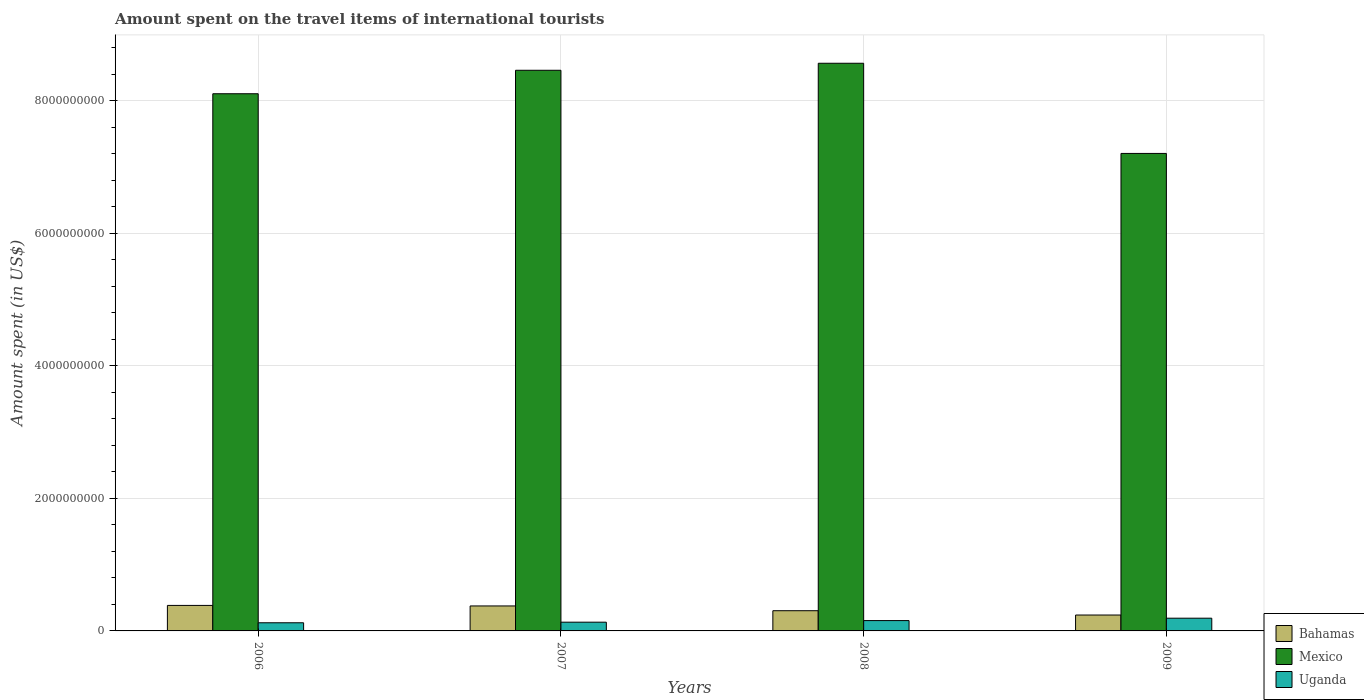How many bars are there on the 1st tick from the left?
Your answer should be compact. 3. How many bars are there on the 4th tick from the right?
Provide a short and direct response. 3. What is the label of the 4th group of bars from the left?
Your response must be concise. 2009. What is the amount spent on the travel items of international tourists in Bahamas in 2008?
Offer a very short reply. 3.05e+08. Across all years, what is the maximum amount spent on the travel items of international tourists in Uganda?
Ensure brevity in your answer.  1.92e+08. Across all years, what is the minimum amount spent on the travel items of international tourists in Bahamas?
Ensure brevity in your answer.  2.40e+08. In which year was the amount spent on the travel items of international tourists in Mexico minimum?
Provide a succinct answer. 2009. What is the total amount spent on the travel items of international tourists in Uganda in the graph?
Your answer should be very brief. 6.03e+08. What is the difference between the amount spent on the travel items of international tourists in Bahamas in 2006 and that in 2007?
Keep it short and to the point. 8.00e+06. What is the difference between the amount spent on the travel items of international tourists in Uganda in 2007 and the amount spent on the travel items of international tourists in Bahamas in 2006?
Offer a terse response. -2.53e+08. What is the average amount spent on the travel items of international tourists in Uganda per year?
Provide a succinct answer. 1.51e+08. In the year 2007, what is the difference between the amount spent on the travel items of international tourists in Mexico and amount spent on the travel items of international tourists in Bahamas?
Ensure brevity in your answer.  8.08e+09. What is the ratio of the amount spent on the travel items of international tourists in Mexico in 2008 to that in 2009?
Give a very brief answer. 1.19. Is the amount spent on the travel items of international tourists in Mexico in 2006 less than that in 2007?
Offer a terse response. Yes. Is the difference between the amount spent on the travel items of international tourists in Mexico in 2007 and 2008 greater than the difference between the amount spent on the travel items of international tourists in Bahamas in 2007 and 2008?
Make the answer very short. No. What is the difference between the highest and the lowest amount spent on the travel items of international tourists in Mexico?
Offer a very short reply. 1.36e+09. In how many years, is the amount spent on the travel items of international tourists in Uganda greater than the average amount spent on the travel items of international tourists in Uganda taken over all years?
Keep it short and to the point. 2. Is the sum of the amount spent on the travel items of international tourists in Uganda in 2007 and 2009 greater than the maximum amount spent on the travel items of international tourists in Bahamas across all years?
Provide a succinct answer. No. What does the 3rd bar from the left in 2008 represents?
Provide a short and direct response. Uganda. What does the 2nd bar from the right in 2006 represents?
Make the answer very short. Mexico. Is it the case that in every year, the sum of the amount spent on the travel items of international tourists in Bahamas and amount spent on the travel items of international tourists in Uganda is greater than the amount spent on the travel items of international tourists in Mexico?
Give a very brief answer. No. How many bars are there?
Make the answer very short. 12. Are all the bars in the graph horizontal?
Keep it short and to the point. No. Does the graph contain any zero values?
Make the answer very short. No. Where does the legend appear in the graph?
Your answer should be very brief. Bottom right. How many legend labels are there?
Provide a succinct answer. 3. What is the title of the graph?
Offer a very short reply. Amount spent on the travel items of international tourists. Does "Benin" appear as one of the legend labels in the graph?
Make the answer very short. No. What is the label or title of the Y-axis?
Provide a succinct answer. Amount spent (in US$). What is the Amount spent (in US$) of Bahamas in 2006?
Ensure brevity in your answer.  3.85e+08. What is the Amount spent (in US$) in Mexico in 2006?
Your answer should be very brief. 8.11e+09. What is the Amount spent (in US$) in Uganda in 2006?
Keep it short and to the point. 1.23e+08. What is the Amount spent (in US$) in Bahamas in 2007?
Provide a short and direct response. 3.77e+08. What is the Amount spent (in US$) in Mexico in 2007?
Offer a very short reply. 8.46e+09. What is the Amount spent (in US$) in Uganda in 2007?
Keep it short and to the point. 1.32e+08. What is the Amount spent (in US$) of Bahamas in 2008?
Make the answer very short. 3.05e+08. What is the Amount spent (in US$) of Mexico in 2008?
Your response must be concise. 8.57e+09. What is the Amount spent (in US$) of Uganda in 2008?
Your answer should be very brief. 1.56e+08. What is the Amount spent (in US$) in Bahamas in 2009?
Your answer should be very brief. 2.40e+08. What is the Amount spent (in US$) in Mexico in 2009?
Ensure brevity in your answer.  7.21e+09. What is the Amount spent (in US$) of Uganda in 2009?
Offer a very short reply. 1.92e+08. Across all years, what is the maximum Amount spent (in US$) in Bahamas?
Keep it short and to the point. 3.85e+08. Across all years, what is the maximum Amount spent (in US$) of Mexico?
Offer a terse response. 8.57e+09. Across all years, what is the maximum Amount spent (in US$) of Uganda?
Provide a short and direct response. 1.92e+08. Across all years, what is the minimum Amount spent (in US$) in Bahamas?
Provide a short and direct response. 2.40e+08. Across all years, what is the minimum Amount spent (in US$) of Mexico?
Provide a short and direct response. 7.21e+09. Across all years, what is the minimum Amount spent (in US$) in Uganda?
Your answer should be compact. 1.23e+08. What is the total Amount spent (in US$) of Bahamas in the graph?
Offer a terse response. 1.31e+09. What is the total Amount spent (in US$) in Mexico in the graph?
Your answer should be compact. 3.23e+1. What is the total Amount spent (in US$) in Uganda in the graph?
Keep it short and to the point. 6.03e+08. What is the difference between the Amount spent (in US$) in Mexico in 2006 and that in 2007?
Your response must be concise. -3.54e+08. What is the difference between the Amount spent (in US$) in Uganda in 2006 and that in 2007?
Your answer should be compact. -9.00e+06. What is the difference between the Amount spent (in US$) in Bahamas in 2006 and that in 2008?
Keep it short and to the point. 8.00e+07. What is the difference between the Amount spent (in US$) in Mexico in 2006 and that in 2008?
Your answer should be very brief. -4.60e+08. What is the difference between the Amount spent (in US$) in Uganda in 2006 and that in 2008?
Offer a terse response. -3.30e+07. What is the difference between the Amount spent (in US$) of Bahamas in 2006 and that in 2009?
Provide a short and direct response. 1.45e+08. What is the difference between the Amount spent (in US$) in Mexico in 2006 and that in 2009?
Make the answer very short. 9.01e+08. What is the difference between the Amount spent (in US$) of Uganda in 2006 and that in 2009?
Provide a short and direct response. -6.90e+07. What is the difference between the Amount spent (in US$) of Bahamas in 2007 and that in 2008?
Provide a short and direct response. 7.20e+07. What is the difference between the Amount spent (in US$) of Mexico in 2007 and that in 2008?
Ensure brevity in your answer.  -1.06e+08. What is the difference between the Amount spent (in US$) in Uganda in 2007 and that in 2008?
Give a very brief answer. -2.40e+07. What is the difference between the Amount spent (in US$) in Bahamas in 2007 and that in 2009?
Offer a very short reply. 1.37e+08. What is the difference between the Amount spent (in US$) in Mexico in 2007 and that in 2009?
Provide a short and direct response. 1.26e+09. What is the difference between the Amount spent (in US$) in Uganda in 2007 and that in 2009?
Offer a terse response. -6.00e+07. What is the difference between the Amount spent (in US$) of Bahamas in 2008 and that in 2009?
Give a very brief answer. 6.50e+07. What is the difference between the Amount spent (in US$) of Mexico in 2008 and that in 2009?
Provide a short and direct response. 1.36e+09. What is the difference between the Amount spent (in US$) in Uganda in 2008 and that in 2009?
Your answer should be compact. -3.60e+07. What is the difference between the Amount spent (in US$) of Bahamas in 2006 and the Amount spent (in US$) of Mexico in 2007?
Give a very brief answer. -8.08e+09. What is the difference between the Amount spent (in US$) in Bahamas in 2006 and the Amount spent (in US$) in Uganda in 2007?
Provide a short and direct response. 2.53e+08. What is the difference between the Amount spent (in US$) of Mexico in 2006 and the Amount spent (in US$) of Uganda in 2007?
Offer a terse response. 7.98e+09. What is the difference between the Amount spent (in US$) in Bahamas in 2006 and the Amount spent (in US$) in Mexico in 2008?
Your response must be concise. -8.18e+09. What is the difference between the Amount spent (in US$) of Bahamas in 2006 and the Amount spent (in US$) of Uganda in 2008?
Your answer should be very brief. 2.29e+08. What is the difference between the Amount spent (in US$) in Mexico in 2006 and the Amount spent (in US$) in Uganda in 2008?
Ensure brevity in your answer.  7.95e+09. What is the difference between the Amount spent (in US$) in Bahamas in 2006 and the Amount spent (in US$) in Mexico in 2009?
Make the answer very short. -6.82e+09. What is the difference between the Amount spent (in US$) in Bahamas in 2006 and the Amount spent (in US$) in Uganda in 2009?
Provide a short and direct response. 1.93e+08. What is the difference between the Amount spent (in US$) of Mexico in 2006 and the Amount spent (in US$) of Uganda in 2009?
Offer a terse response. 7.92e+09. What is the difference between the Amount spent (in US$) of Bahamas in 2007 and the Amount spent (in US$) of Mexico in 2008?
Make the answer very short. -8.19e+09. What is the difference between the Amount spent (in US$) in Bahamas in 2007 and the Amount spent (in US$) in Uganda in 2008?
Provide a short and direct response. 2.21e+08. What is the difference between the Amount spent (in US$) in Mexico in 2007 and the Amount spent (in US$) in Uganda in 2008?
Give a very brief answer. 8.31e+09. What is the difference between the Amount spent (in US$) in Bahamas in 2007 and the Amount spent (in US$) in Mexico in 2009?
Your answer should be compact. -6.83e+09. What is the difference between the Amount spent (in US$) in Bahamas in 2007 and the Amount spent (in US$) in Uganda in 2009?
Make the answer very short. 1.85e+08. What is the difference between the Amount spent (in US$) in Mexico in 2007 and the Amount spent (in US$) in Uganda in 2009?
Give a very brief answer. 8.27e+09. What is the difference between the Amount spent (in US$) of Bahamas in 2008 and the Amount spent (in US$) of Mexico in 2009?
Ensure brevity in your answer.  -6.90e+09. What is the difference between the Amount spent (in US$) in Bahamas in 2008 and the Amount spent (in US$) in Uganda in 2009?
Provide a succinct answer. 1.13e+08. What is the difference between the Amount spent (in US$) of Mexico in 2008 and the Amount spent (in US$) of Uganda in 2009?
Your answer should be compact. 8.38e+09. What is the average Amount spent (in US$) of Bahamas per year?
Your answer should be very brief. 3.27e+08. What is the average Amount spent (in US$) in Mexico per year?
Ensure brevity in your answer.  8.09e+09. What is the average Amount spent (in US$) of Uganda per year?
Your answer should be compact. 1.51e+08. In the year 2006, what is the difference between the Amount spent (in US$) of Bahamas and Amount spent (in US$) of Mexico?
Offer a terse response. -7.72e+09. In the year 2006, what is the difference between the Amount spent (in US$) of Bahamas and Amount spent (in US$) of Uganda?
Your answer should be compact. 2.62e+08. In the year 2006, what is the difference between the Amount spent (in US$) of Mexico and Amount spent (in US$) of Uganda?
Provide a short and direct response. 7.98e+09. In the year 2007, what is the difference between the Amount spent (in US$) in Bahamas and Amount spent (in US$) in Mexico?
Ensure brevity in your answer.  -8.08e+09. In the year 2007, what is the difference between the Amount spent (in US$) of Bahamas and Amount spent (in US$) of Uganda?
Give a very brief answer. 2.45e+08. In the year 2007, what is the difference between the Amount spent (in US$) of Mexico and Amount spent (in US$) of Uganda?
Offer a terse response. 8.33e+09. In the year 2008, what is the difference between the Amount spent (in US$) in Bahamas and Amount spent (in US$) in Mexico?
Your response must be concise. -8.26e+09. In the year 2008, what is the difference between the Amount spent (in US$) of Bahamas and Amount spent (in US$) of Uganda?
Your response must be concise. 1.49e+08. In the year 2008, what is the difference between the Amount spent (in US$) of Mexico and Amount spent (in US$) of Uganda?
Your response must be concise. 8.41e+09. In the year 2009, what is the difference between the Amount spent (in US$) in Bahamas and Amount spent (in US$) in Mexico?
Keep it short and to the point. -6.97e+09. In the year 2009, what is the difference between the Amount spent (in US$) of Bahamas and Amount spent (in US$) of Uganda?
Keep it short and to the point. 4.80e+07. In the year 2009, what is the difference between the Amount spent (in US$) in Mexico and Amount spent (in US$) in Uganda?
Provide a short and direct response. 7.02e+09. What is the ratio of the Amount spent (in US$) of Bahamas in 2006 to that in 2007?
Provide a short and direct response. 1.02. What is the ratio of the Amount spent (in US$) of Mexico in 2006 to that in 2007?
Ensure brevity in your answer.  0.96. What is the ratio of the Amount spent (in US$) in Uganda in 2006 to that in 2007?
Your answer should be very brief. 0.93. What is the ratio of the Amount spent (in US$) in Bahamas in 2006 to that in 2008?
Make the answer very short. 1.26. What is the ratio of the Amount spent (in US$) in Mexico in 2006 to that in 2008?
Keep it short and to the point. 0.95. What is the ratio of the Amount spent (in US$) of Uganda in 2006 to that in 2008?
Ensure brevity in your answer.  0.79. What is the ratio of the Amount spent (in US$) in Bahamas in 2006 to that in 2009?
Your answer should be compact. 1.6. What is the ratio of the Amount spent (in US$) of Mexico in 2006 to that in 2009?
Provide a succinct answer. 1.12. What is the ratio of the Amount spent (in US$) in Uganda in 2006 to that in 2009?
Keep it short and to the point. 0.64. What is the ratio of the Amount spent (in US$) of Bahamas in 2007 to that in 2008?
Your response must be concise. 1.24. What is the ratio of the Amount spent (in US$) of Mexico in 2007 to that in 2008?
Ensure brevity in your answer.  0.99. What is the ratio of the Amount spent (in US$) in Uganda in 2007 to that in 2008?
Ensure brevity in your answer.  0.85. What is the ratio of the Amount spent (in US$) of Bahamas in 2007 to that in 2009?
Offer a terse response. 1.57. What is the ratio of the Amount spent (in US$) of Mexico in 2007 to that in 2009?
Offer a terse response. 1.17. What is the ratio of the Amount spent (in US$) in Uganda in 2007 to that in 2009?
Make the answer very short. 0.69. What is the ratio of the Amount spent (in US$) of Bahamas in 2008 to that in 2009?
Keep it short and to the point. 1.27. What is the ratio of the Amount spent (in US$) of Mexico in 2008 to that in 2009?
Your answer should be compact. 1.19. What is the ratio of the Amount spent (in US$) in Uganda in 2008 to that in 2009?
Provide a succinct answer. 0.81. What is the difference between the highest and the second highest Amount spent (in US$) in Mexico?
Keep it short and to the point. 1.06e+08. What is the difference between the highest and the second highest Amount spent (in US$) in Uganda?
Your response must be concise. 3.60e+07. What is the difference between the highest and the lowest Amount spent (in US$) in Bahamas?
Keep it short and to the point. 1.45e+08. What is the difference between the highest and the lowest Amount spent (in US$) of Mexico?
Provide a short and direct response. 1.36e+09. What is the difference between the highest and the lowest Amount spent (in US$) in Uganda?
Your answer should be very brief. 6.90e+07. 